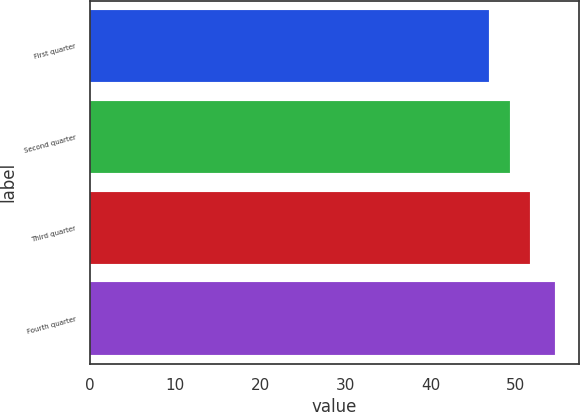Convert chart. <chart><loc_0><loc_0><loc_500><loc_500><bar_chart><fcel>First quarter<fcel>Second quarter<fcel>Third quarter<fcel>Fourth quarter<nl><fcel>46.91<fcel>49.33<fcel>51.71<fcel>54.64<nl></chart> 